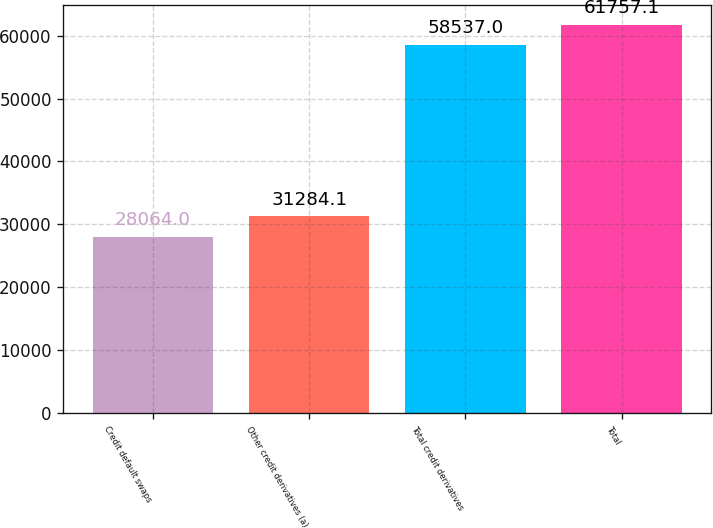Convert chart. <chart><loc_0><loc_0><loc_500><loc_500><bar_chart><fcel>Credit default swaps<fcel>Other credit derivatives (a)<fcel>Total credit derivatives<fcel>Total<nl><fcel>28064<fcel>31284.1<fcel>58537<fcel>61757.1<nl></chart> 